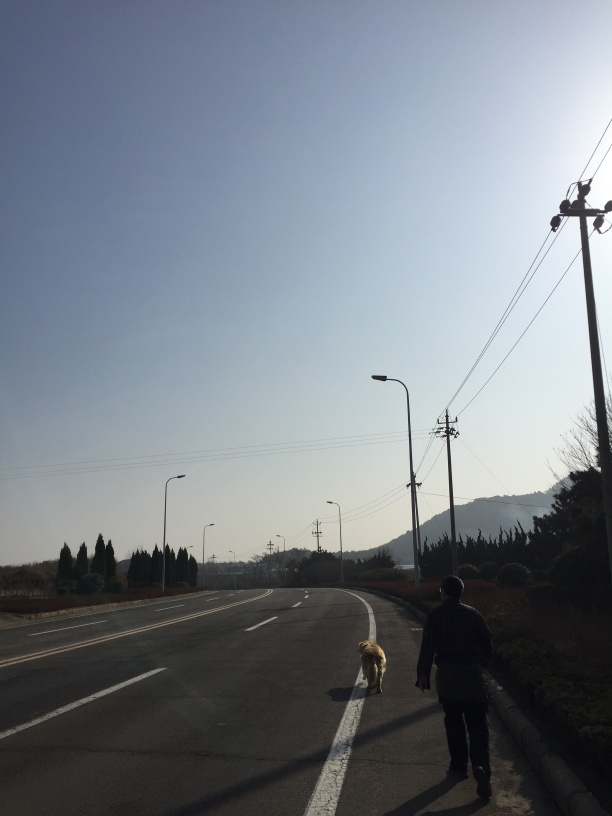Is the overall clarity of the image low? The image has moderate clarity. While the subjects in the image—such as the person walking a dog, the trees, and the street—are distinguishable, there is some haziness in the atmosphere, likely due to the lighting or weather conditions, which slightly reduces the overall sharpness of the image. 